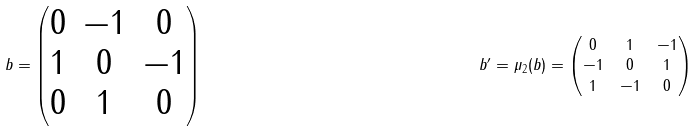Convert formula to latex. <formula><loc_0><loc_0><loc_500><loc_500>b = \begin{pmatrix} 0 & - 1 & 0 \\ 1 & 0 & - 1 \\ 0 & 1 & 0 \end{pmatrix} & & b ^ { \prime } = \mu _ { 2 } ( b ) = \begin{pmatrix} 0 & 1 & - 1 \\ - 1 & 0 & 1 \\ 1 & - 1 & 0 \end{pmatrix}</formula> 